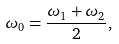<formula> <loc_0><loc_0><loc_500><loc_500>\omega _ { 0 } = \frac { \omega _ { 1 } + \omega _ { 2 } } { 2 } ,</formula> 